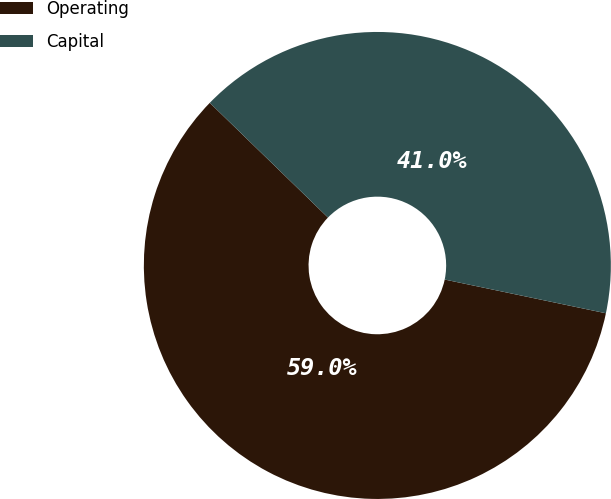<chart> <loc_0><loc_0><loc_500><loc_500><pie_chart><fcel>Operating<fcel>Capital<nl><fcel>58.98%<fcel>41.02%<nl></chart> 